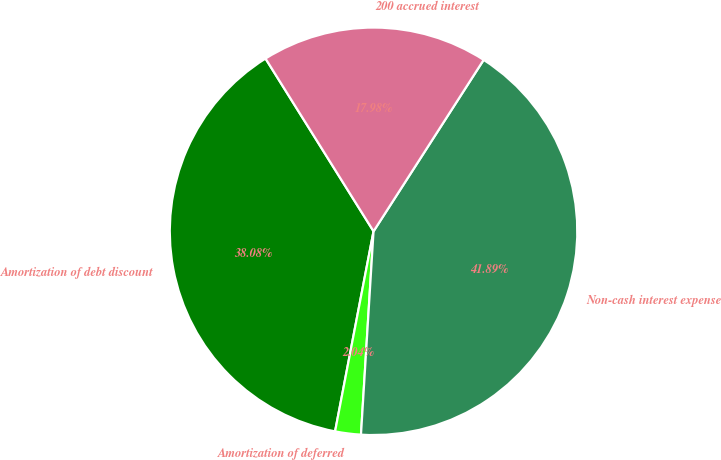<chart> <loc_0><loc_0><loc_500><loc_500><pie_chart><fcel>Amortization of debt discount<fcel>Amortization of deferred<fcel>Non-cash interest expense<fcel>200 accrued interest<nl><fcel>38.08%<fcel>2.04%<fcel>41.89%<fcel>17.98%<nl></chart> 